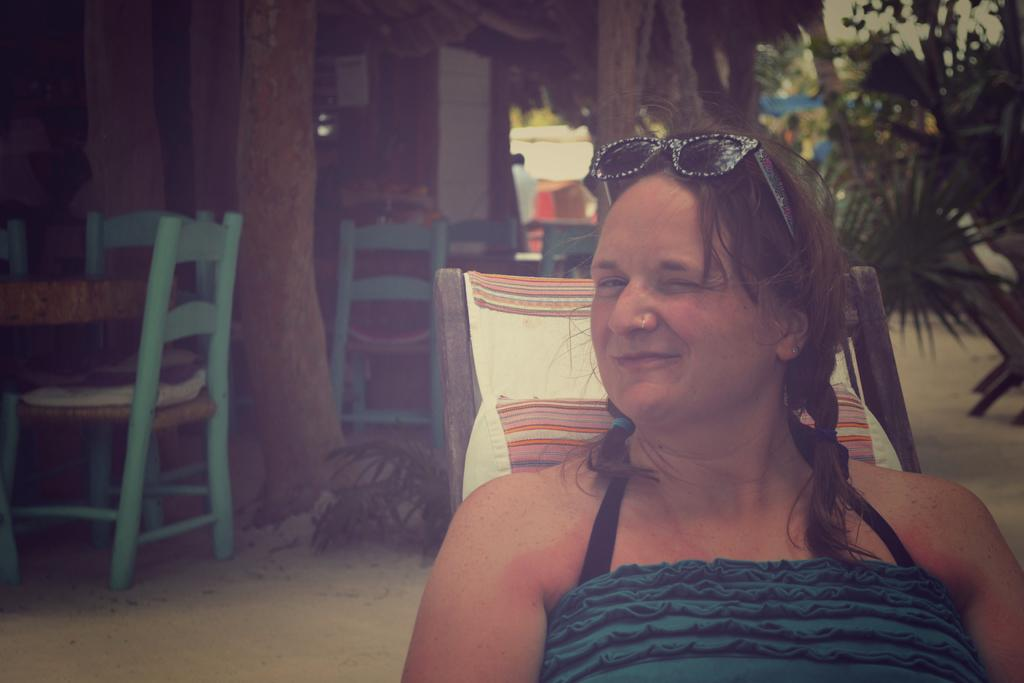What is the woman in the image doing? The woman is sitting in the image. What expression does the woman have? The woman is smiling. What is the woman sitting on? The woman is sitting in a chair. What can be seen in the background of the image? There are chairs, tables, trees, buildings, and the sky visible in the background of the image. What type of rock can be seen whistling in the image? There is no rock present in the image, and rocks cannot whistle. 